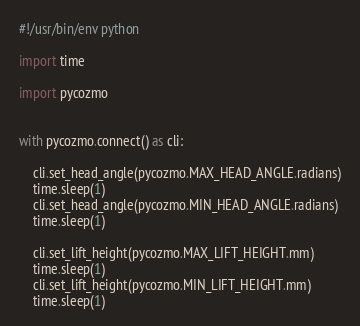Convert code to text. <code><loc_0><loc_0><loc_500><loc_500><_Python_>#!/usr/bin/env python

import time

import pycozmo


with pycozmo.connect() as cli:

    cli.set_head_angle(pycozmo.MAX_HEAD_ANGLE.radians)
    time.sleep(1)
    cli.set_head_angle(pycozmo.MIN_HEAD_ANGLE.radians)
    time.sleep(1)

    cli.set_lift_height(pycozmo.MAX_LIFT_HEIGHT.mm)
    time.sleep(1)
    cli.set_lift_height(pycozmo.MIN_LIFT_HEIGHT.mm)
    time.sleep(1)
</code> 